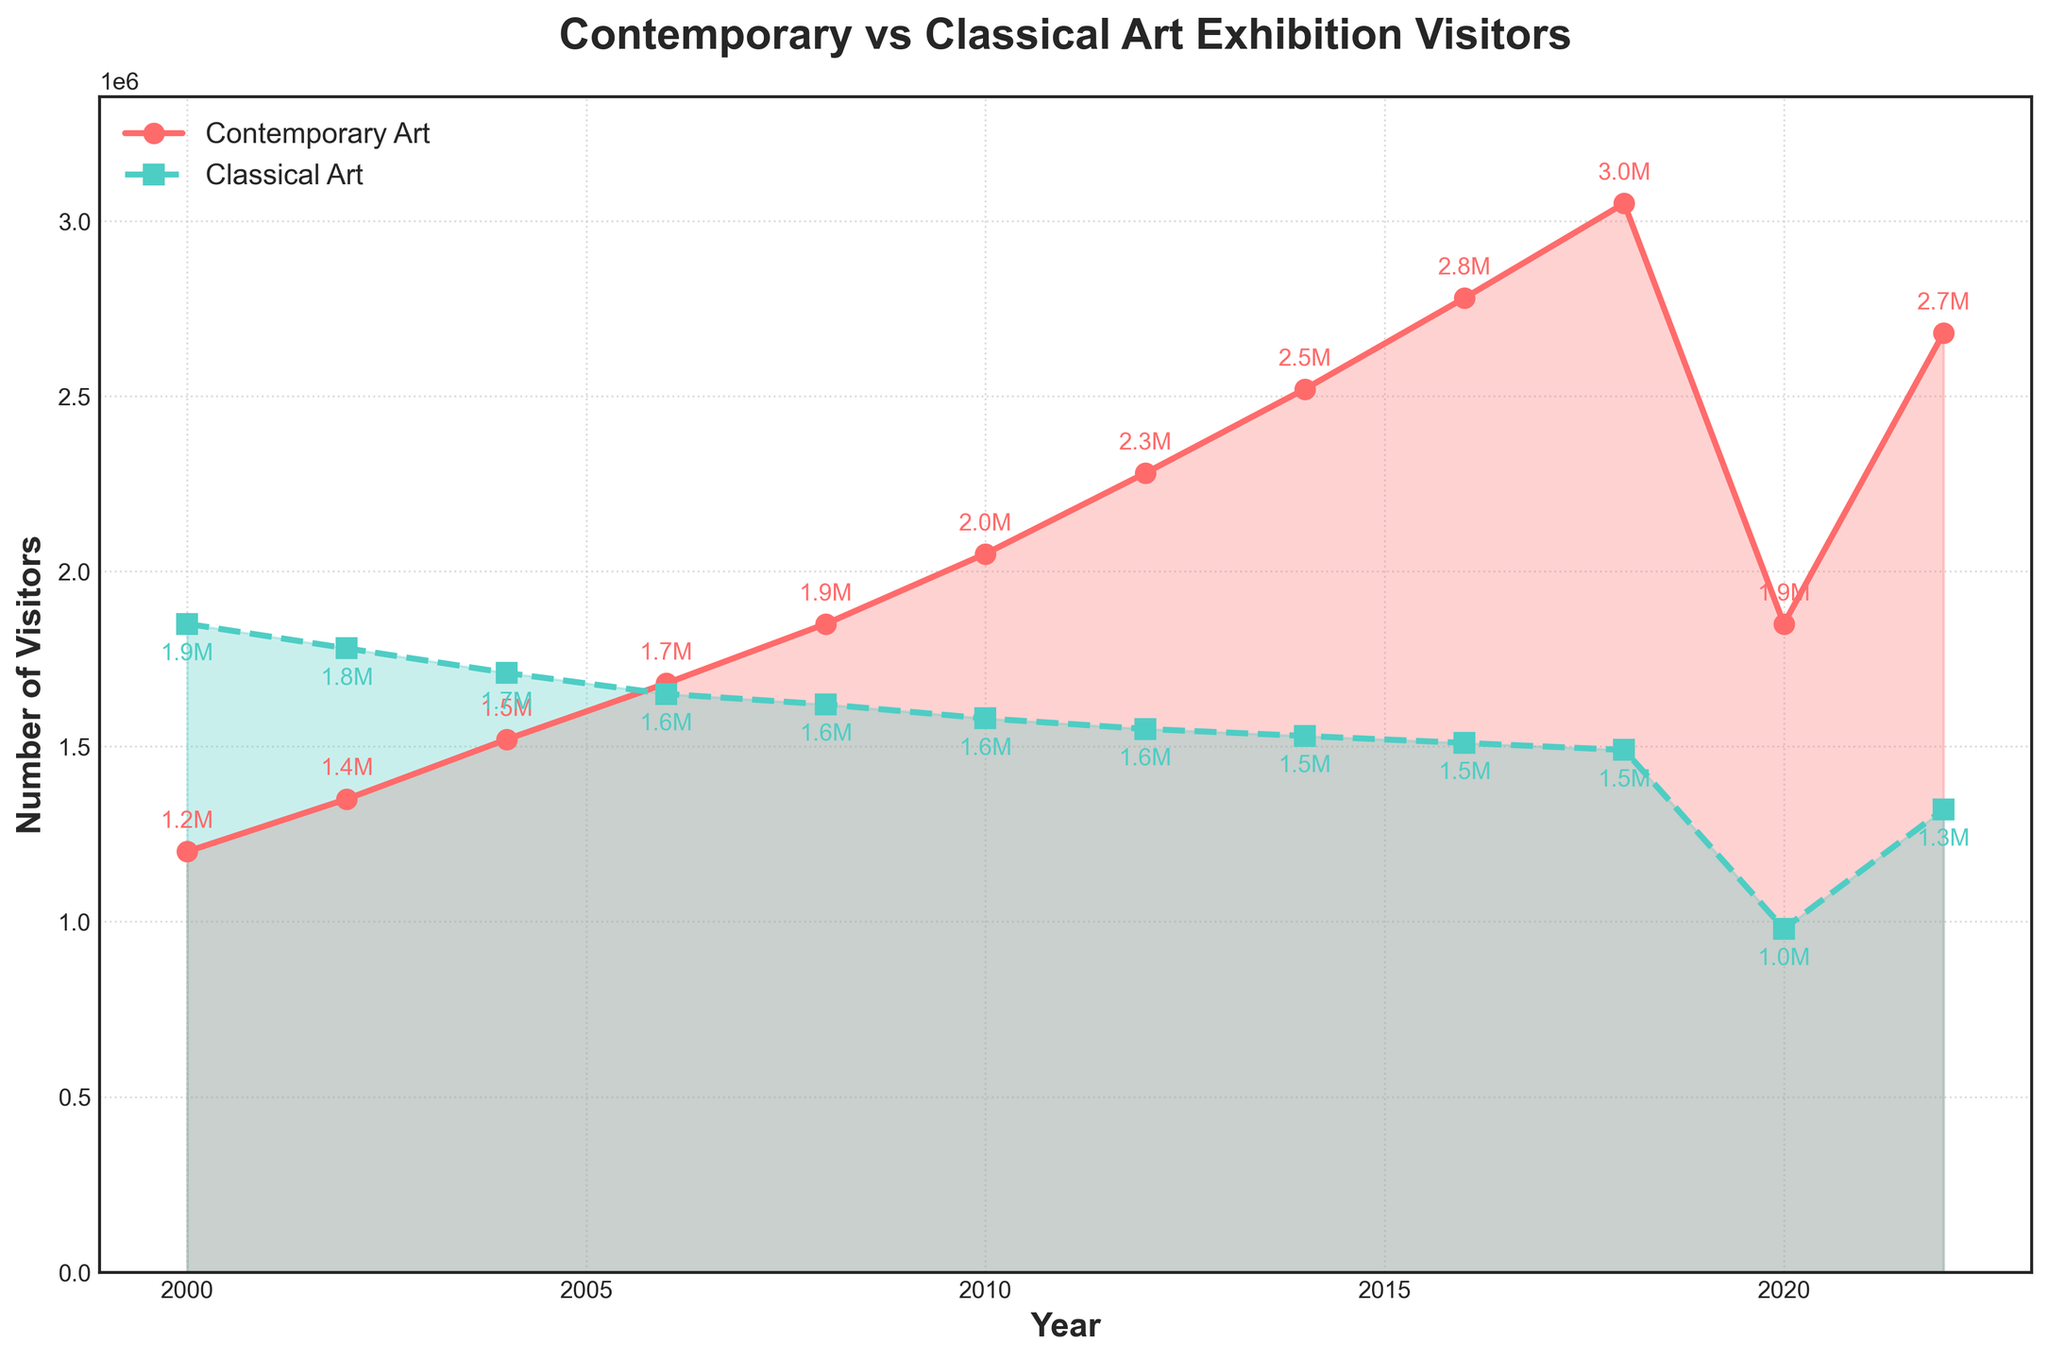Which year had the highest number of visitors for contemporary art exhibitions? By examining the red line on the plot, the year where the red line reaches its peak indicates the highest number of visitors for contemporary art exhibitions.
Answer: 2018 How did the number of visitors for classical art exhibitions change from 2000 to 2022? Look at the green line on the plot from the leftmost point (2000) to the rightmost point (2022). The trend shows a decrease.
Answer: Declined What is the difference in the number of visitors between contemporary and classical art exhibitions in 2022? Find the visitor numbers for both types of exhibitions in 2022 on the plot, and then subtract the number of classical art visitors from the number of contemporary art visitors for that year.
Answer: 1,360,000 During which period did contemporary art exhibitions witness the steepest increase in visitor numbers? Identify the segment of the red line that has the steepest slope upwards by visually inspecting the plot. This is around the point where the line rises sharply.
Answer: 2016-2018 How did the number of visitors to contemporary art exhibitions change from 2018 to 2020? Locate the red line on the plot between the years 2018 and 2020 and observe the trend; it shows a sharp decline.
Answer: Decreased Which type of art exhibition had more visitors during 2008? Compare the red and green lines or the corresponding data points for the year 2008 and see which is higher.
Answer: Contemporary Art What approximate percentage drop did classical art exhibitions experience from 2018 to 2020? Determine the visitor counts from 2018 and 2020 for classical art exhibitions and then calculate the percentage drop: ((1490000 - 980000) / 1490000) * 100.
Answer: 34.2% What was the combined number of visitors for both contemporary and classical art exhibitions in 2016? Add the number of visitors for contemporary art exhibitions in 2016 to classical art exhibitions in the same year by referring to the plot.
Answer: 4,290,000 Which year saw the equal number of visitors for both exhibitions? By looking at where the red and green lines intersect, identify the year where both lines are at the same height.
Answer: No year (the lines do not intersect) What was the general trend for both types of art exhibitions from 2000 to 2020? Identify the overall shape of both lines from the leftmost point (2000) to the point just before the end (2020).
Answer: Contemporary increased, Classical decreased 